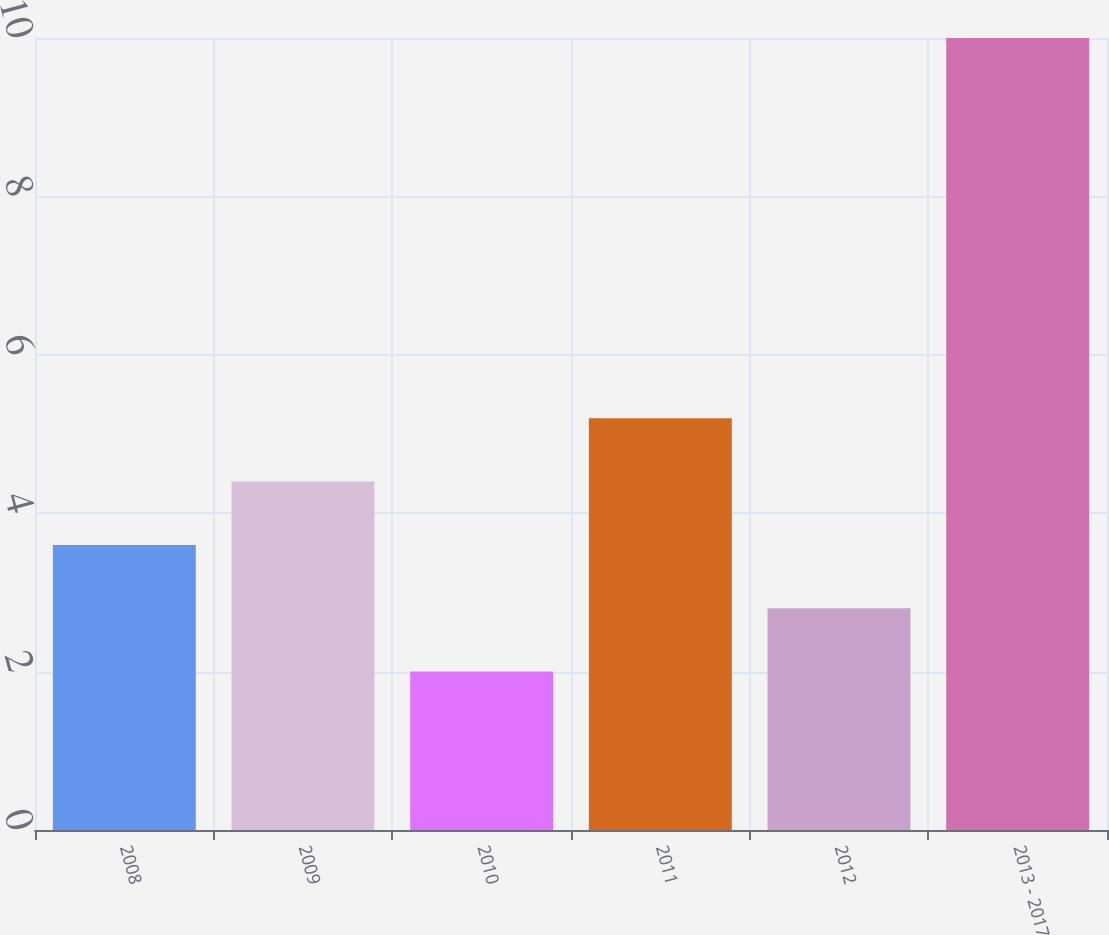Convert chart to OTSL. <chart><loc_0><loc_0><loc_500><loc_500><bar_chart><fcel>2008<fcel>2009<fcel>2010<fcel>2011<fcel>2012<fcel>2013 - 2017<nl><fcel>3.6<fcel>4.4<fcel>2<fcel>5.2<fcel>2.8<fcel>10<nl></chart> 